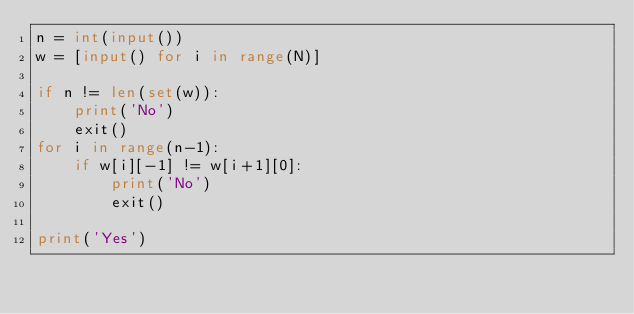<code> <loc_0><loc_0><loc_500><loc_500><_Python_>n = int(input())
w = [input() for i in range(N)]

if n != len(set(w)):
    print('No')
    exit()
for i in range(n-1):
    if w[i][-1] != w[i+1][0]:
        print('No')
        exit()

print('Yes')</code> 